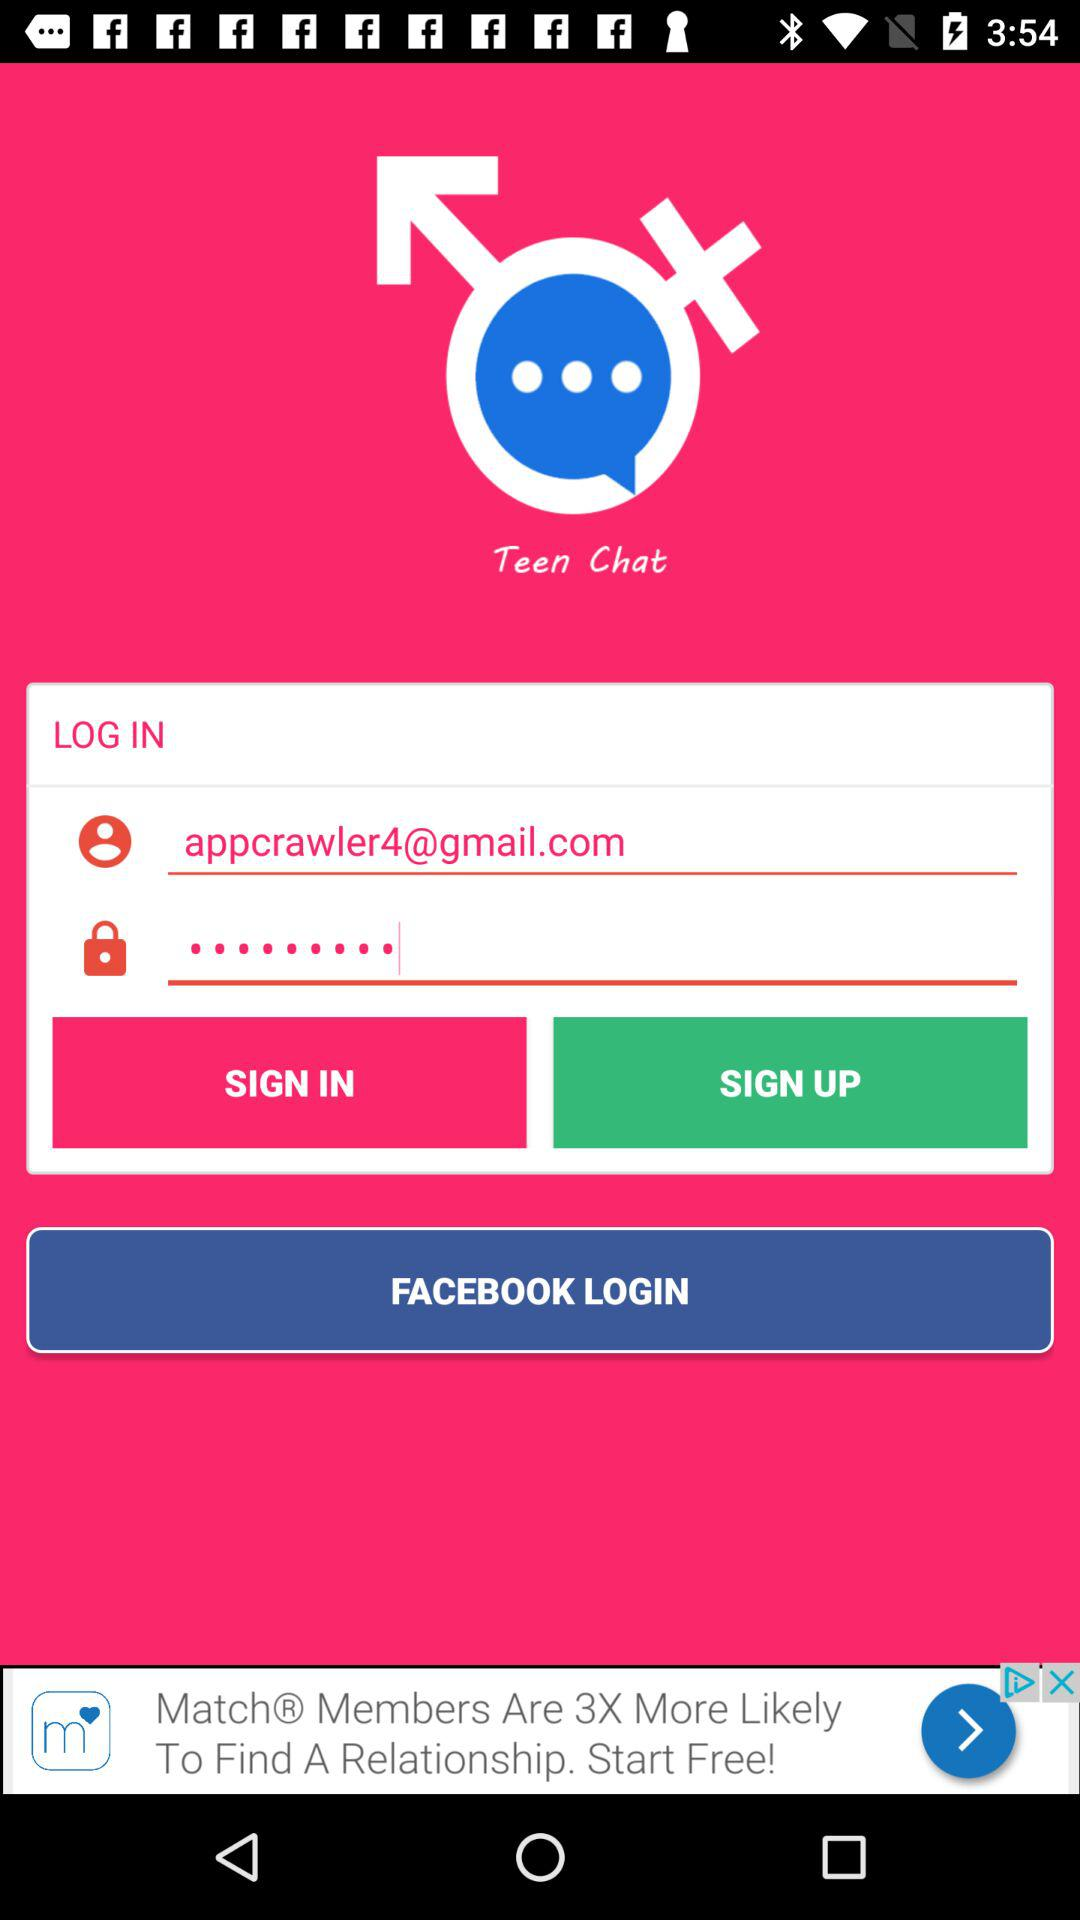What is the app name? The app name is "Teen Chat". 